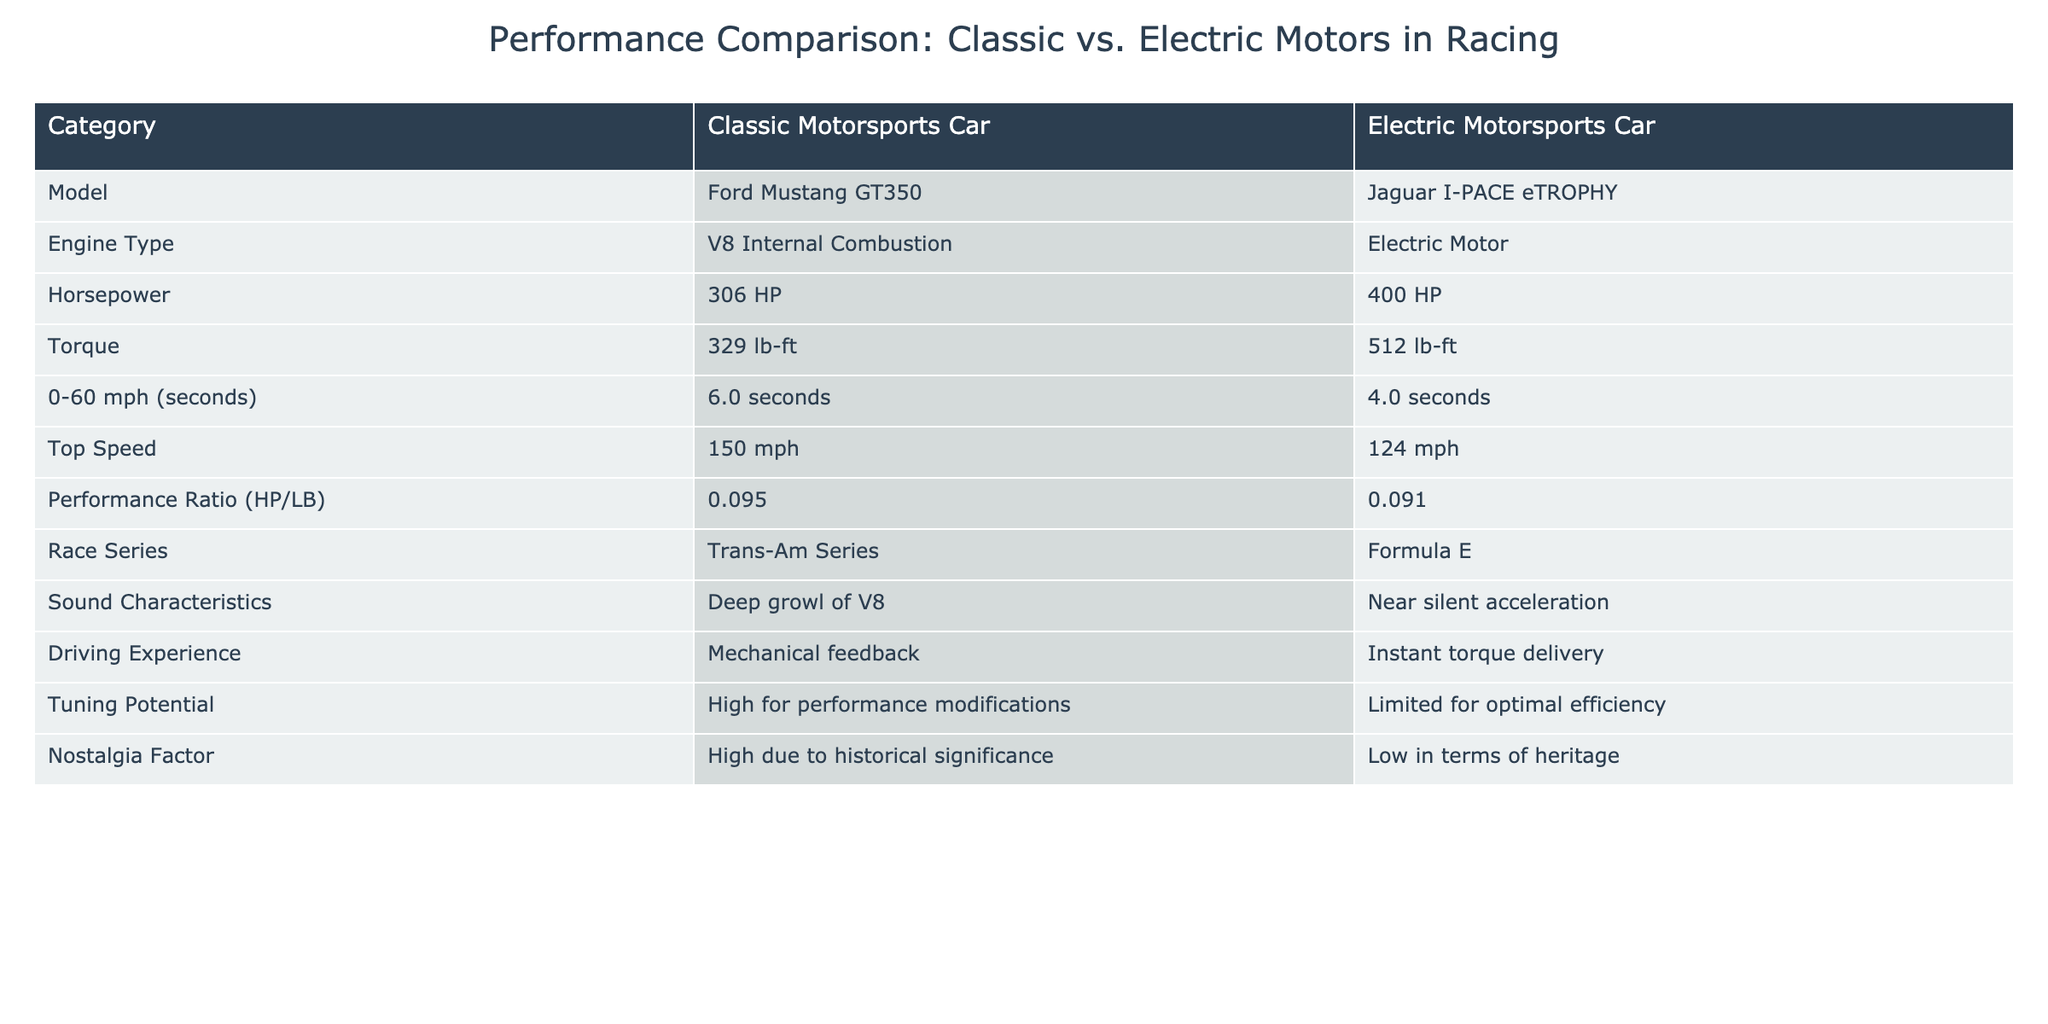What is the horsepower of the classic motorsports car? From the table, I can see that the horsepower of the Ford Mustang GT350, the classic motorsports car, is listed clearly under the Horsepower category.
Answer: 306 HP How much torque does the electric motorsports car deliver? The torque for the Jaguar I-PACE eTROPHY, the electric motorsports car, is found in the Torque row of the table. The value provided there helps answer the question directly.
Answer: 512 lb-ft Which car has a faster 0-60 mph time? The 0-60 mph times for both cars are listed in the respective rows. Comparing 6.0 seconds for the Ford Mustang with 4.0 seconds for the Jaguar I-PACE eTROPHY indicates that the electric car accelerates faster to 60 mph.
Answer: Jaguar I-PACE eTROPHY Is the sound characteristic of the classic motorsport car more appealing based on the table? According to the Sound Characteristics row in the table, the Ford Mustang GT350 has a "Deep growl of V8," which can be considered more appealing than the "Near silent acceleration" of the electric car for many enthusiasts.
Answer: Yes What is the difference in horsepower between the two cars? To find the difference, I subtract the electric car's horsepower (400 HP) from the classic car's horsepower (306 HP). Thus, the difference is 400 HP - 306 HP = 94 HP.
Answer: 94 HP Which car has a higher performance ratio? The Performance Ratio for the classic car is 0.095 HP/LB and for the electric car, it is 0.091 HP/LB. A comparison of these values shows that the classic car has a higher performance ratio.
Answer: Classic Motorsports Car What is the median horsepower of these two cars? The two values for horsepower are 306 HP and 400 HP. To find the median of these two numbers, I take their average: (306 HP + 400 HP) / 2 = 353 HP.
Answer: 353 HP Does the classic motorsports car have a high nostalgia factor? Looking at the Nostalgia Factor row of the table, the classic Ford Mustang GT350 is noted to have a "High" nostalgia factor due to its historical significance, confirming its appeal in this aspect.
Answer: Yes Which car has limited tuning potential? The Tuning Potential row indicates that the electric motorsports car has "Limited for optimal efficiency," while the classic car is noted to have "High for performance modifications." Therefore, the electric car has limited tuning potential.
Answer: Electric Motorsports Car 